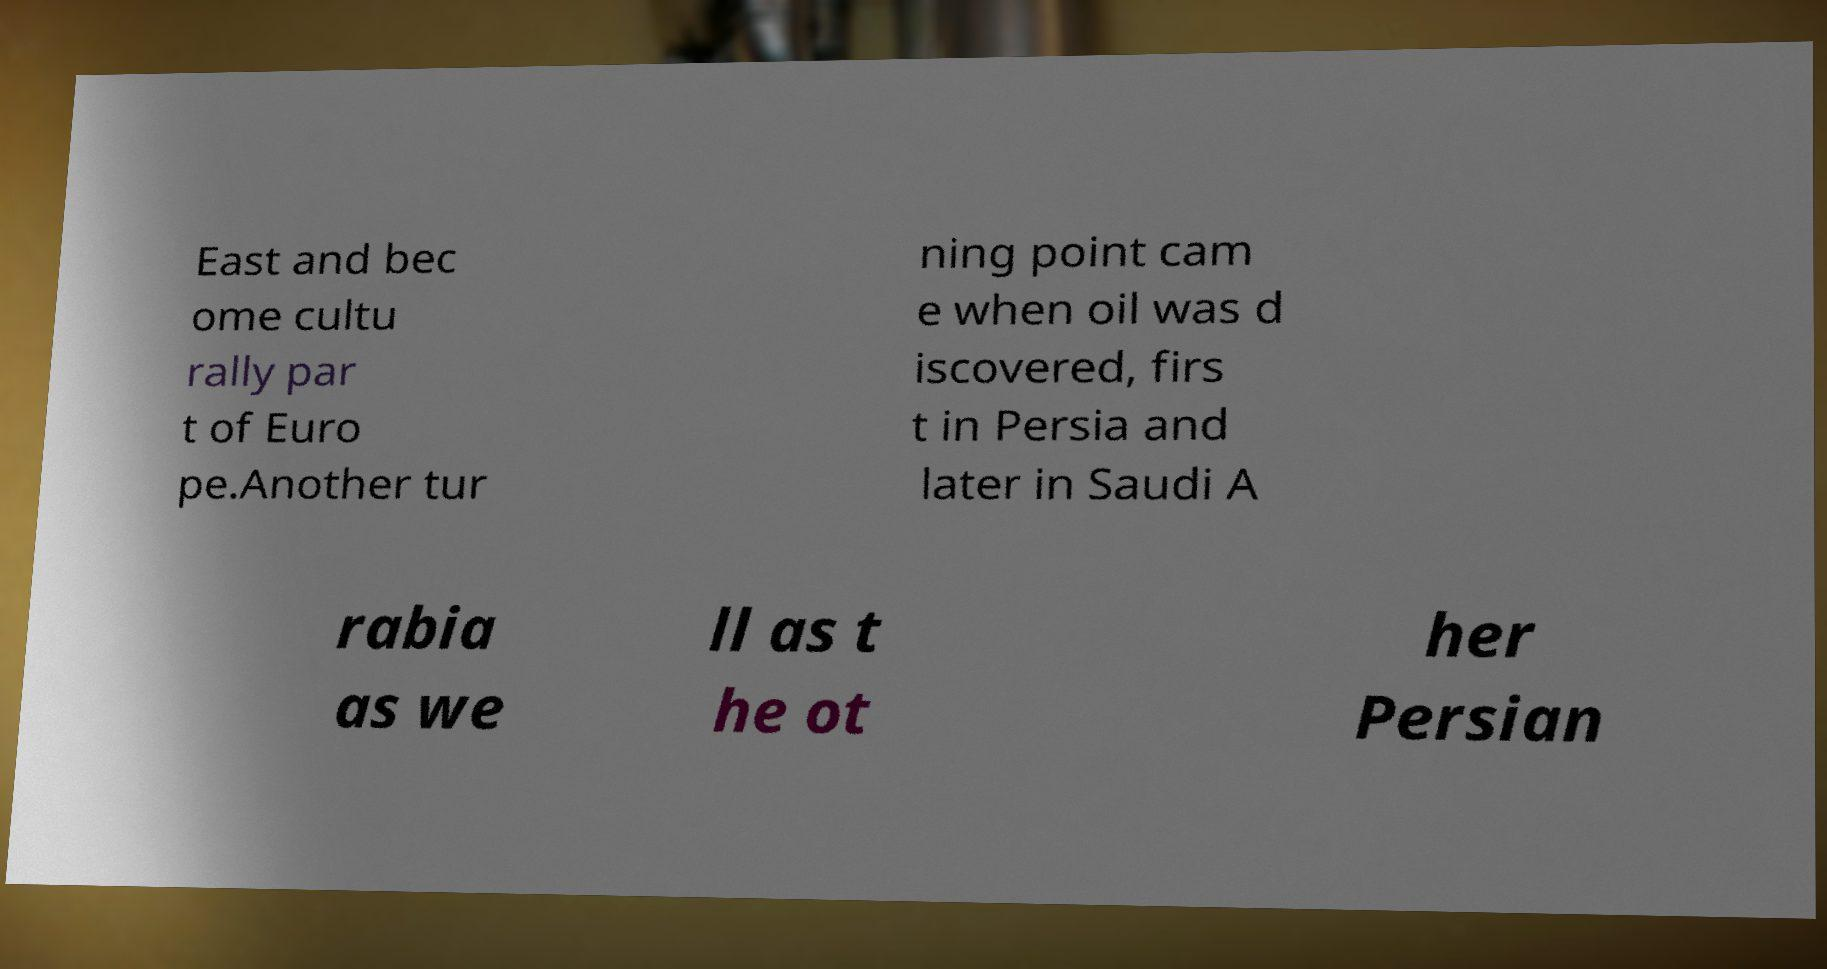Please identify and transcribe the text found in this image. East and bec ome cultu rally par t of Euro pe.Another tur ning point cam e when oil was d iscovered, firs t in Persia and later in Saudi A rabia as we ll as t he ot her Persian 